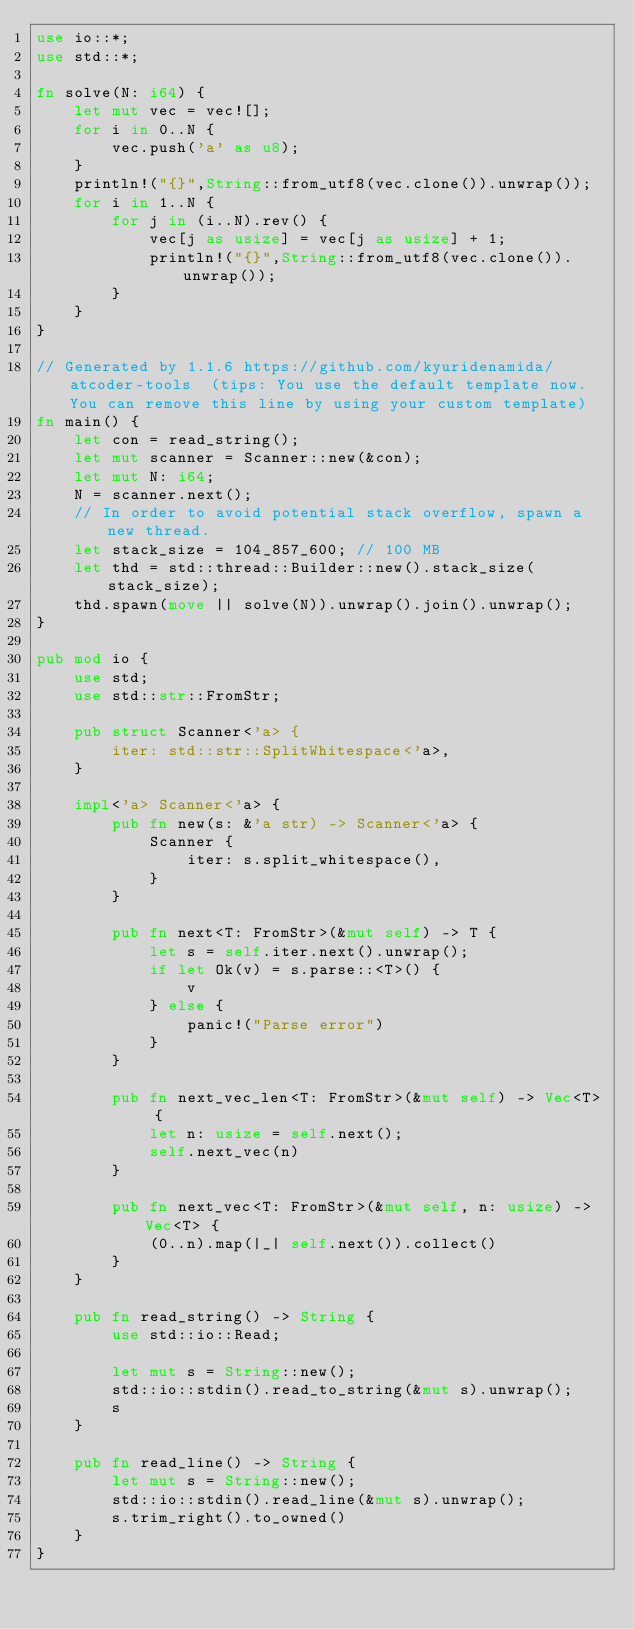<code> <loc_0><loc_0><loc_500><loc_500><_Rust_>use io::*;
use std::*;

fn solve(N: i64) {
    let mut vec = vec![];
    for i in 0..N {
        vec.push('a' as u8);
    }
    println!("{}",String::from_utf8(vec.clone()).unwrap());
    for i in 1..N {
        for j in (i..N).rev() {
            vec[j as usize] = vec[j as usize] + 1;
            println!("{}",String::from_utf8(vec.clone()).unwrap());
        }
    }
}

// Generated by 1.1.6 https://github.com/kyuridenamida/atcoder-tools  (tips: You use the default template now. You can remove this line by using your custom template)
fn main() {
    let con = read_string();
    let mut scanner = Scanner::new(&con);
    let mut N: i64;
    N = scanner.next();
    // In order to avoid potential stack overflow, spawn a new thread.
    let stack_size = 104_857_600; // 100 MB
    let thd = std::thread::Builder::new().stack_size(stack_size);
    thd.spawn(move || solve(N)).unwrap().join().unwrap();
}

pub mod io {
    use std;
    use std::str::FromStr;

    pub struct Scanner<'a> {
        iter: std::str::SplitWhitespace<'a>,
    }

    impl<'a> Scanner<'a> {
        pub fn new(s: &'a str) -> Scanner<'a> {
            Scanner {
                iter: s.split_whitespace(),
            }
        }

        pub fn next<T: FromStr>(&mut self) -> T {
            let s = self.iter.next().unwrap();
            if let Ok(v) = s.parse::<T>() {
                v
            } else {
                panic!("Parse error")
            }
        }

        pub fn next_vec_len<T: FromStr>(&mut self) -> Vec<T> {
            let n: usize = self.next();
            self.next_vec(n)
        }

        pub fn next_vec<T: FromStr>(&mut self, n: usize) -> Vec<T> {
            (0..n).map(|_| self.next()).collect()
        }
    }

    pub fn read_string() -> String {
        use std::io::Read;

        let mut s = String::new();
        std::io::stdin().read_to_string(&mut s).unwrap();
        s
    }

    pub fn read_line() -> String {
        let mut s = String::new();
        std::io::stdin().read_line(&mut s).unwrap();
        s.trim_right().to_owned()
    }
}
</code> 